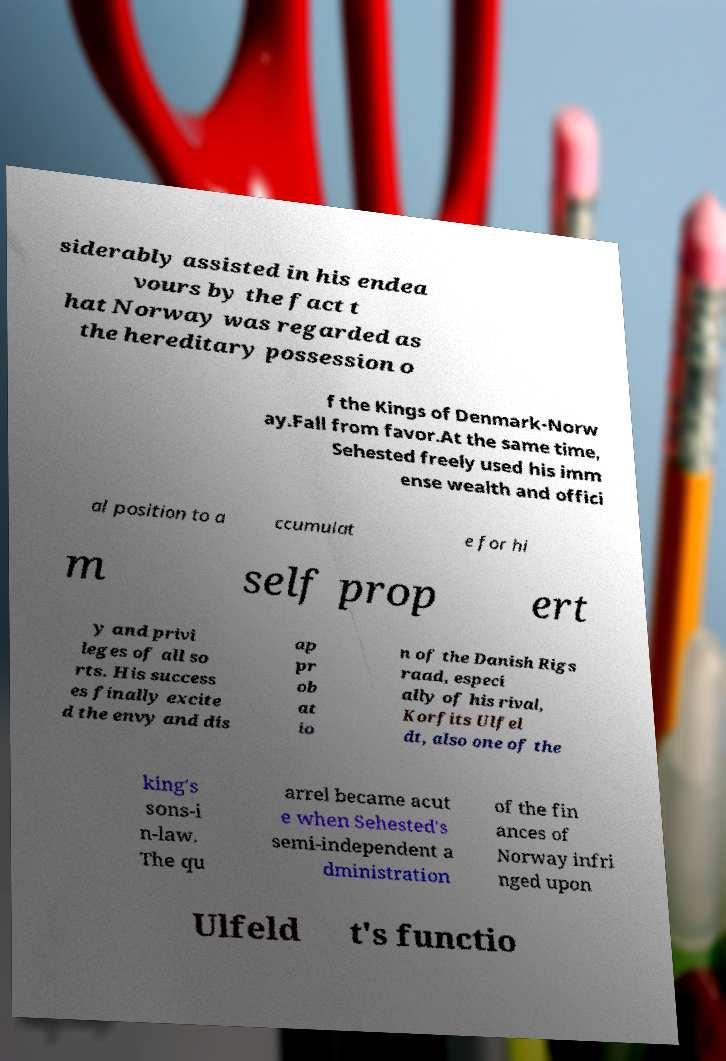Can you accurately transcribe the text from the provided image for me? siderably assisted in his endea vours by the fact t hat Norway was regarded as the hereditary possession o f the Kings of Denmark-Norw ay.Fall from favor.At the same time, Sehested freely used his imm ense wealth and offici al position to a ccumulat e for hi m self prop ert y and privi leges of all so rts. His success es finally excite d the envy and dis ap pr ob at io n of the Danish Rigs raad, especi ally of his rival, Korfits Ulfel dt, also one of the king's sons-i n-law. The qu arrel became acut e when Sehested's semi-independent a dministration of the fin ances of Norway infri nged upon Ulfeld t's functio 